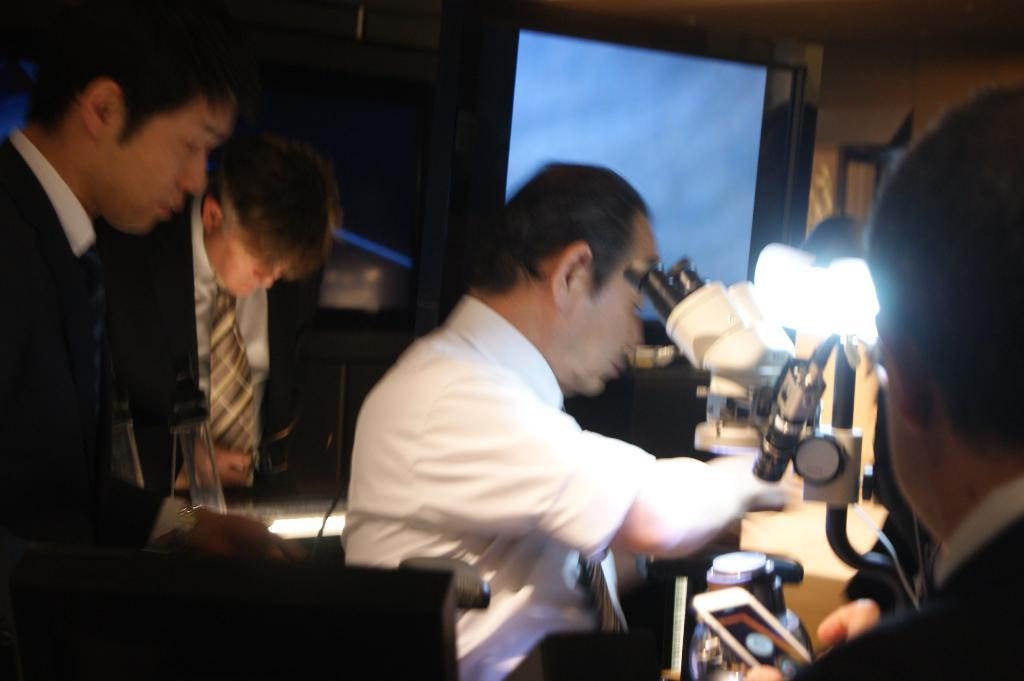How many people are in the image? There is a group of people in the image, but the exact number is not specified. What is one of the objects present in the image? Yes, there is a television in the image. What type of structure can be seen in the image? There is a wall in the image. Can you describe the objects present in the image? There are objects present in the image, but the specific objects are not mentioned in the facts. Is there a guitar being played by one of the people in the image? There is no mention of a guitar in the image, so it cannot be determined if one is being played. Are there any pests visible in the image? There is no mention of pests in the image, so it cannot be determined if any are present. 